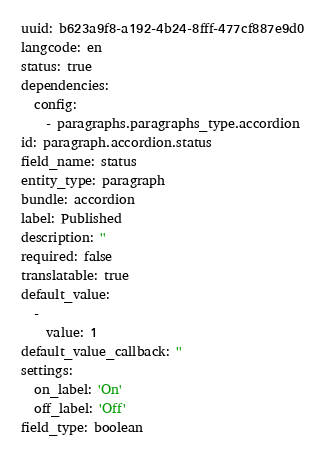Convert code to text. <code><loc_0><loc_0><loc_500><loc_500><_YAML_>uuid: b623a9f8-a192-4b24-8fff-477cf887e9d0
langcode: en
status: true
dependencies:
  config:
    - paragraphs.paragraphs_type.accordion
id: paragraph.accordion.status
field_name: status
entity_type: paragraph
bundle: accordion
label: Published
description: ''
required: false
translatable: true
default_value:
  -
    value: 1
default_value_callback: ''
settings:
  on_label: 'On'
  off_label: 'Off'
field_type: boolean
</code> 